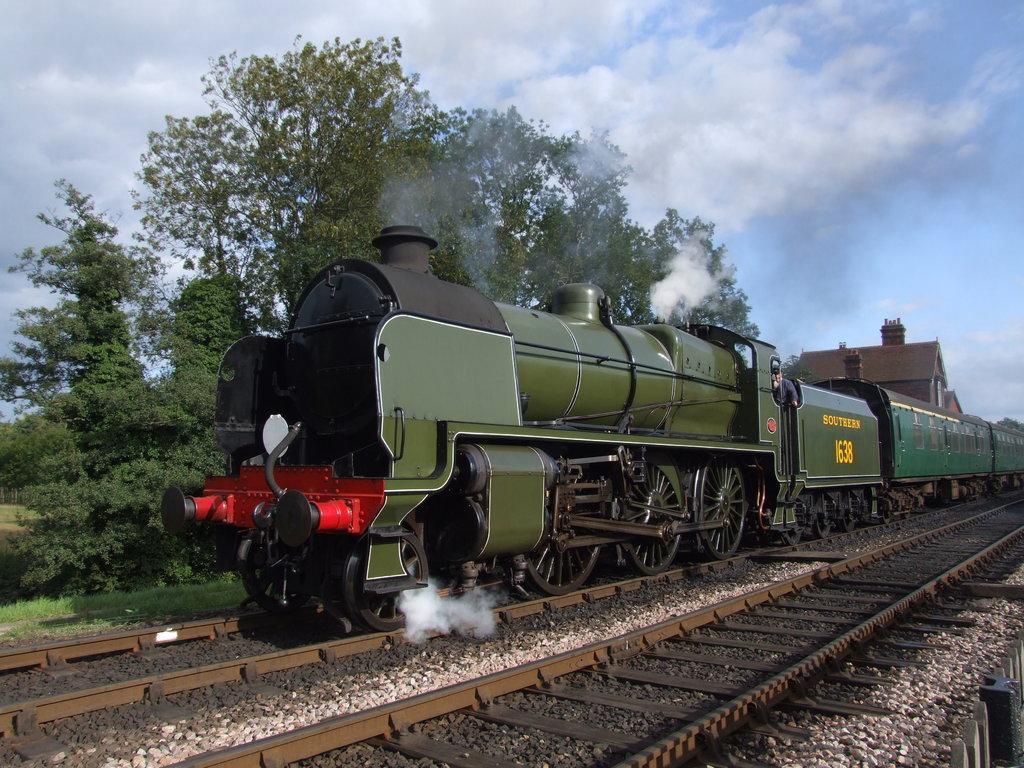In one or two sentences, can you explain what this image depicts? In the image we can see a train, on the train track. This is a train track, stones, grass, trees and a cloudy sky. This is a smoke. 